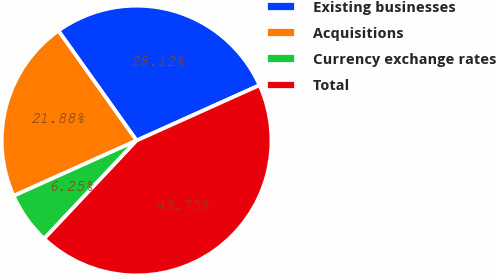Convert chart. <chart><loc_0><loc_0><loc_500><loc_500><pie_chart><fcel>Existing businesses<fcel>Acquisitions<fcel>Currency exchange rates<fcel>Total<nl><fcel>28.12%<fcel>21.88%<fcel>6.25%<fcel>43.75%<nl></chart> 